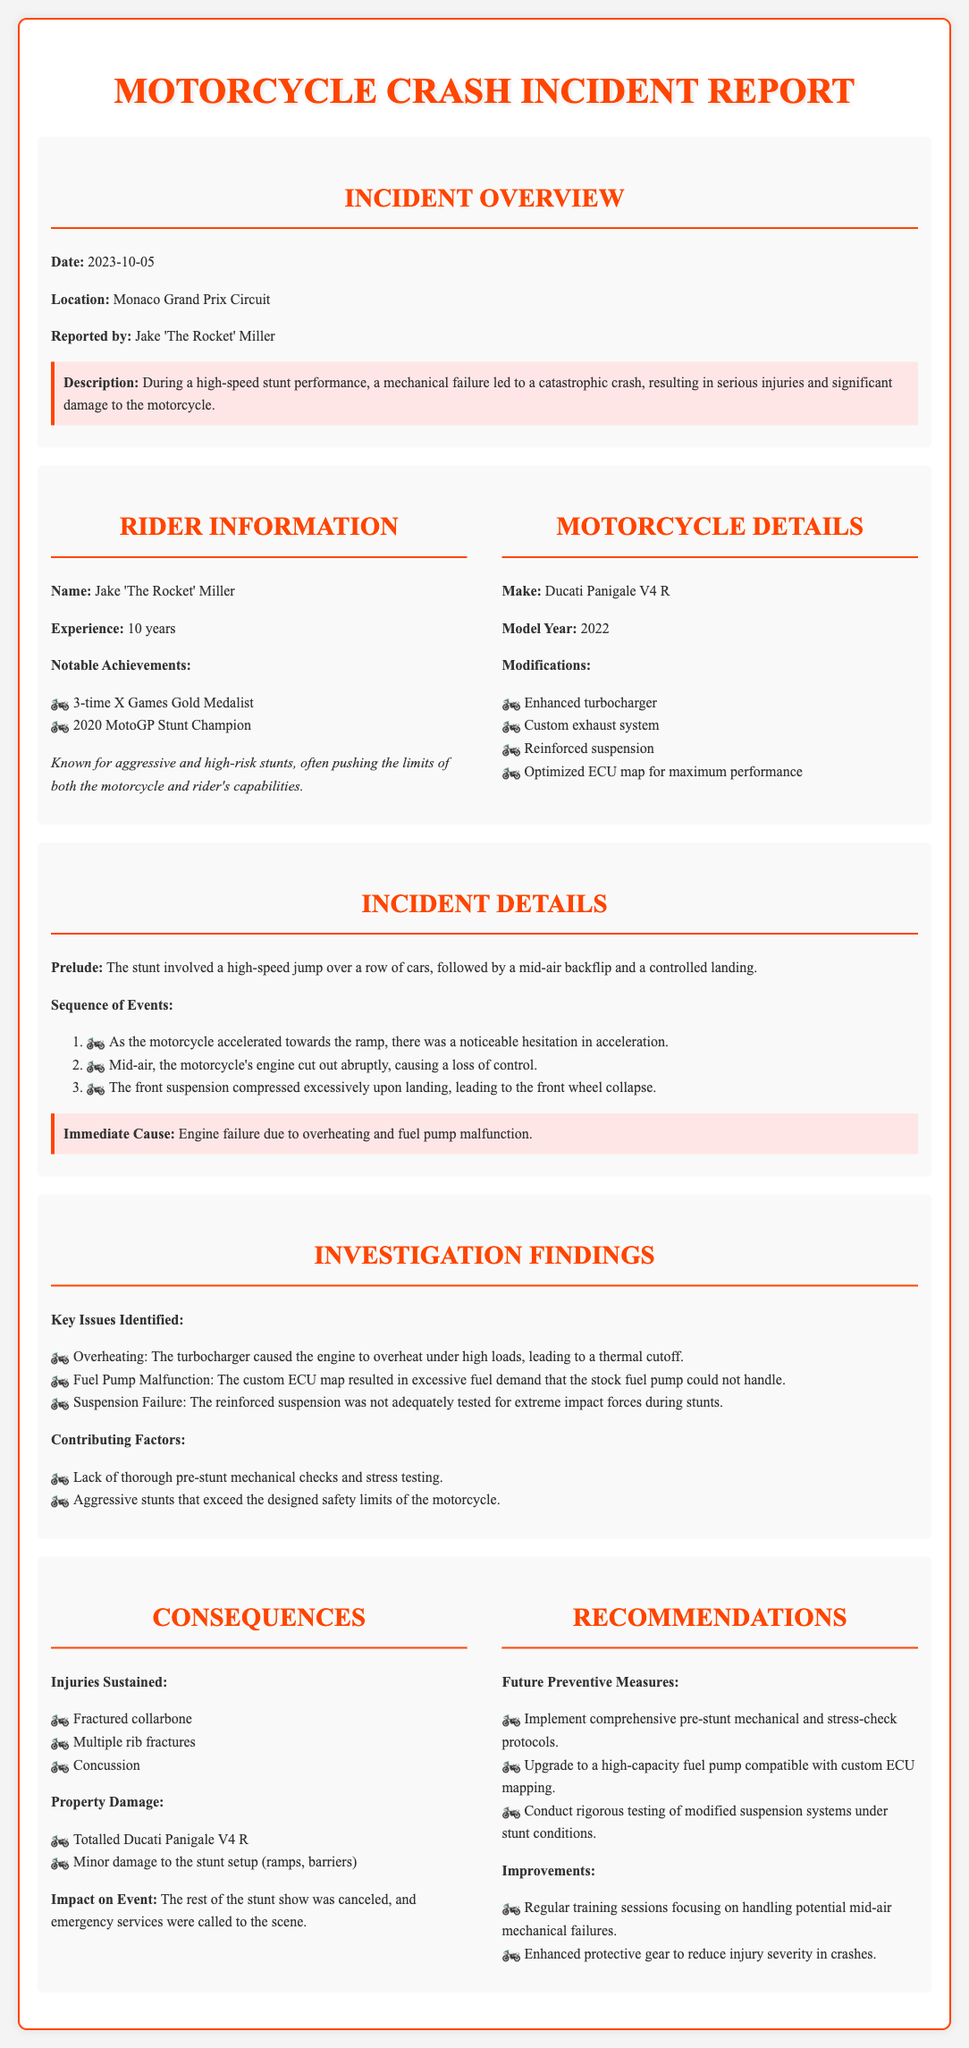what is the date of the incident? The incident occurred on October 5, 2023.
Answer: October 5, 2023 where did the incident take place? The location of the incident is specified as the Monaco Grand Prix Circuit.
Answer: Monaco Grand Prix Circuit who reported the incident? The report was made by Jake 'The Rocket' Miller.
Answer: Jake 'The Rocket' Miller what motorcycle was involved in the crash? The motorcycle involved was a Ducati Panigale V4 R.
Answer: Ducati Panigale V4 R how many years of experience does the rider have? The rider has 10 years of experience.
Answer: 10 years what was the immediate cause of the crash? The immediate cause of the crash was engine failure due to overheating and fuel pump malfunction.
Answer: Engine failure due to overheating and fuel pump malfunction what was one of the key issues identified during the investigation? One of the key issues identified was overheating caused by the turbocharger.
Answer: Overheating which safety measure is recommended for the future? A recommended safety measure is to implement comprehensive pre-stunt mechanical and stress-check protocols.
Answer: Comprehensive pre-stunt mechanical and stress-check protocols how many significant injuries did the rider sustain? The rider sustained three significant injuries.
Answer: Three 